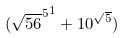Convert formula to latex. <formula><loc_0><loc_0><loc_500><loc_500>( { \sqrt { 5 6 } ^ { 5 } } ^ { 1 } + 1 0 ^ { \sqrt { 5 } } )</formula> 